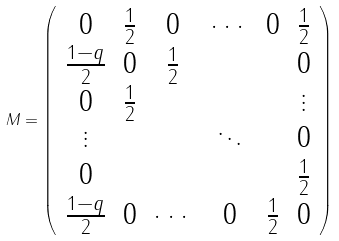Convert formula to latex. <formula><loc_0><loc_0><loc_500><loc_500>M = \left ( \begin{array} { c c c c c c } 0 & \frac { 1 } { 2 } & 0 & \cdots & 0 & \frac { 1 } { 2 } \\ \frac { 1 - q } { 2 } & 0 & \frac { 1 } { 2 } & & & 0 \\ 0 & \frac { 1 } { 2 } & & & & \vdots \\ \vdots & & & \ddots & & 0 \\ 0 & & & & & \frac { 1 } { 2 } \\ \frac { 1 - q } { 2 } & 0 & \cdots & 0 & \frac { 1 } { 2 } & 0 \end{array} \right )</formula> 